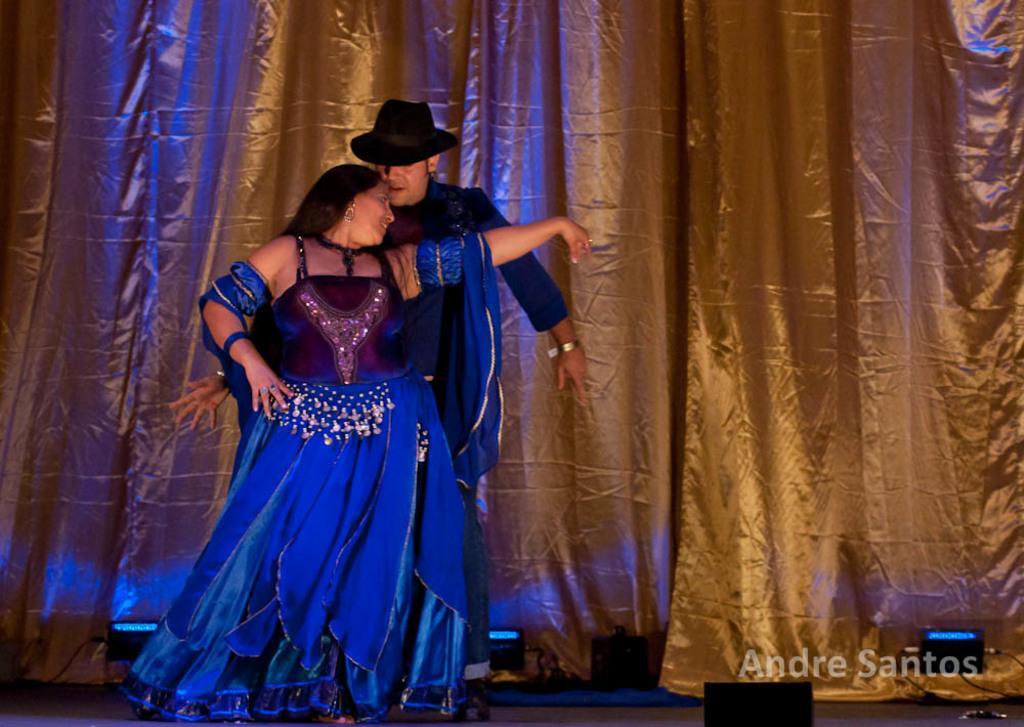Describe this image in one or two sentences. In this image in the center there are persons dancing on the stage, there are lights and in the background there is a curtain. At the bottom right of the image there is some text which is visible. 